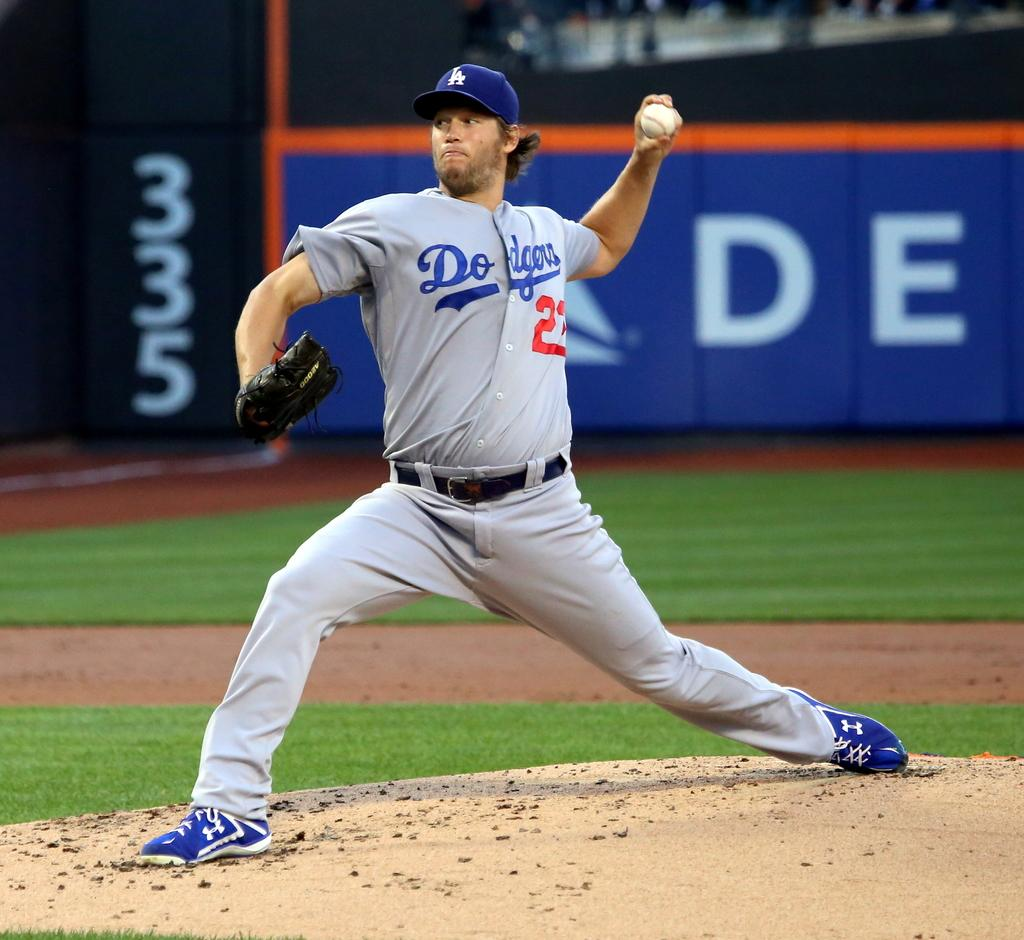Provide a one-sentence caption for the provided image. The Dodgers pitcher, number 22 is in the process of throwing the ball. 